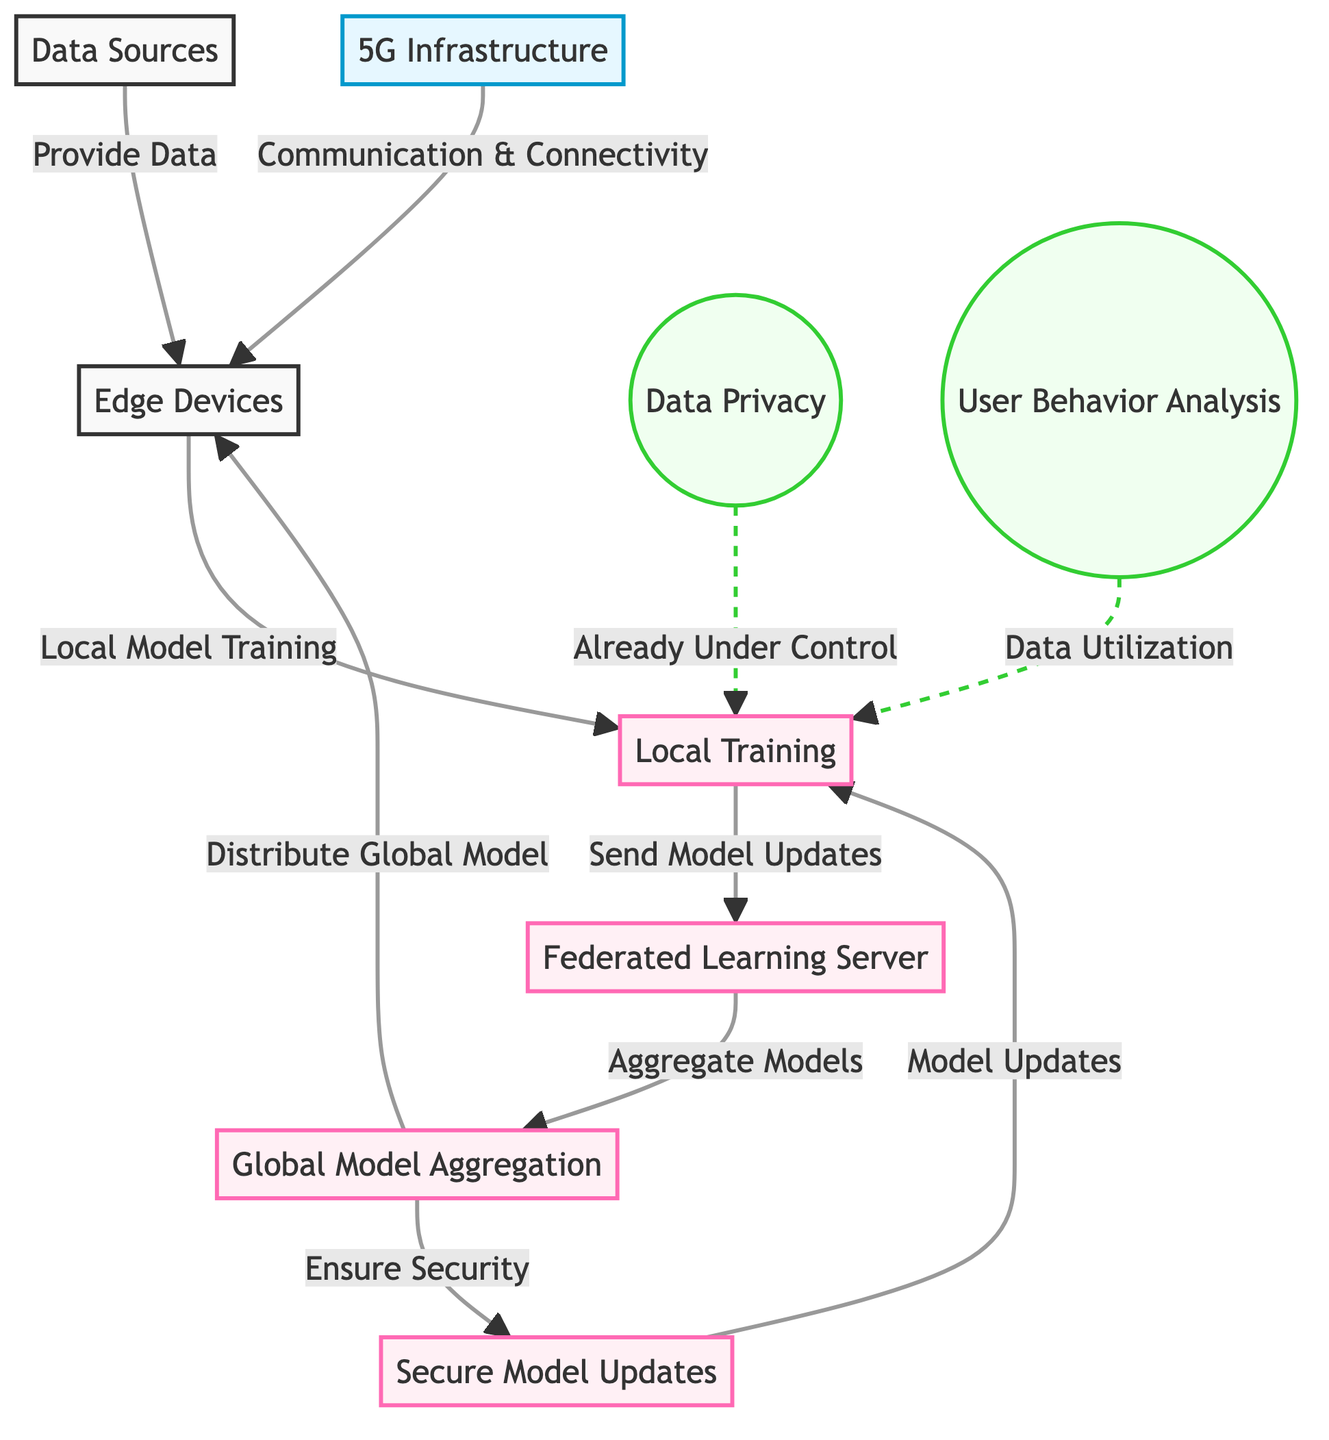What are the two main analyses represented in the diagram? The diagram includes two analysis nodes: Data Privacy and User Behavior Analysis. These are indicated by the circles labeled with those terms.
Answer: Data Privacy, User Behavior Analysis How many main processes are involved in enhancing data security? The diagram shows five main processes, indicated by squares that involve local training, the federated learning server, global model aggregation, secure model updates, and communication with edge devices.
Answer: Five What does the 5G Infrastructure provide to the Edge Devices? According to the diagram, the 5G Infrastructure provides Communication & Connectivity, which is shown as the connecting line from the 5G Infrastructure to the Edge Devices.
Answer: Communication & Connectivity What type of model does the Federated Learning Server work with? The Federated Learning Server works with model updates received from local training processes. This connection is indicated by the arrow leading to the Federated Learning Server from the Local Training node.
Answer: Model updates How does the Global Model Aggregation ensure security? The Global Model Aggregation connects to the Secure Model Updates process, indicating that it ensures security by distributing and aggregating secure model updates as part of the overall training workflow.
Answer: By distributing secure model updates Why are Data Privacy and User Behavior Analysis dashed lines leading to Local Training? The dashed lines indicate that both analyses, Data Privacy and User Behavior Analysis, provide feedback or conditions related to Local Training, suggesting that these aspects are considered in the local model training process.
Answer: Feedback considerations What is the first step from Edge Devices in the diagram? The first step from Edge Devices is Local Model Training, as indicated by the arrow leading from Edge Devices to the Local Training node.
Answer: Local Model Training How many nodes are dedicated to processes in this diagram? There are five nodes dedicated to processes: Local Training, Federated Learning Server, Global Model Aggregation, Secure Model Updates, and Edge Devices.
Answer: Five 